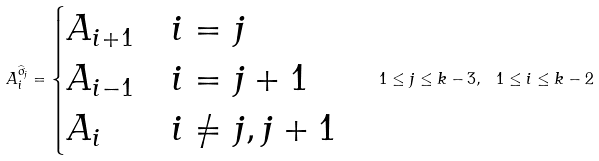<formula> <loc_0><loc_0><loc_500><loc_500>A _ { i } ^ { \widehat { \sigma } _ { j } } = \begin{cases} A _ { i + 1 } & i = j \\ A _ { i - 1 } & i = j + 1 \\ A _ { i } & i \neq j , j + 1 \end{cases} \quad 1 \leq j \leq k - 3 , \ 1 \leq i \leq k - 2</formula> 